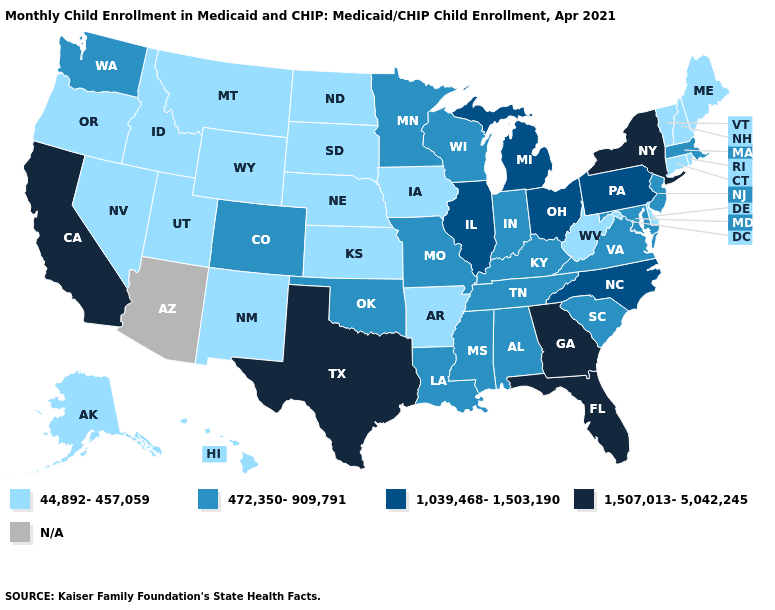What is the highest value in the USA?
Be succinct. 1,507,013-5,042,245. Does Georgia have the highest value in the South?
Give a very brief answer. Yes. Name the states that have a value in the range 44,892-457,059?
Give a very brief answer. Alaska, Arkansas, Connecticut, Delaware, Hawaii, Idaho, Iowa, Kansas, Maine, Montana, Nebraska, Nevada, New Hampshire, New Mexico, North Dakota, Oregon, Rhode Island, South Dakota, Utah, Vermont, West Virginia, Wyoming. What is the lowest value in states that border Arkansas?
Give a very brief answer. 472,350-909,791. Among the states that border Louisiana , which have the lowest value?
Quick response, please. Arkansas. What is the value of New Mexico?
Keep it brief. 44,892-457,059. Name the states that have a value in the range N/A?
Concise answer only. Arizona. What is the lowest value in states that border North Dakota?
Answer briefly. 44,892-457,059. Which states hav the highest value in the Northeast?
Concise answer only. New York. Name the states that have a value in the range 472,350-909,791?
Short answer required. Alabama, Colorado, Indiana, Kentucky, Louisiana, Maryland, Massachusetts, Minnesota, Mississippi, Missouri, New Jersey, Oklahoma, South Carolina, Tennessee, Virginia, Washington, Wisconsin. Among the states that border Wisconsin , does Michigan have the highest value?
Quick response, please. Yes. What is the lowest value in states that border Idaho?
Answer briefly. 44,892-457,059. Among the states that border Colorado , which have the lowest value?
Give a very brief answer. Kansas, Nebraska, New Mexico, Utah, Wyoming. Does the map have missing data?
Concise answer only. Yes. Name the states that have a value in the range 472,350-909,791?
Give a very brief answer. Alabama, Colorado, Indiana, Kentucky, Louisiana, Maryland, Massachusetts, Minnesota, Mississippi, Missouri, New Jersey, Oklahoma, South Carolina, Tennessee, Virginia, Washington, Wisconsin. 